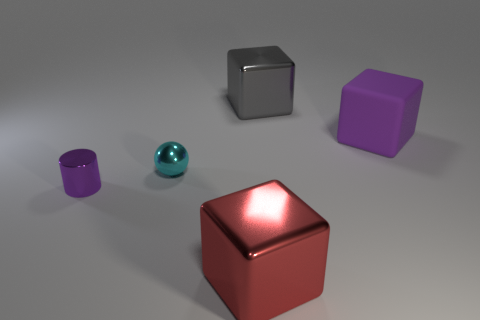Is there anything else that is the same size as the red block? The purple block appears to be the same size as the red block. However, without precise measurements, one cannot assert that they're exactly the same size. They do share similar characteristics such as shape and reflective surface, which may contribute to a perception of them being the same size. 